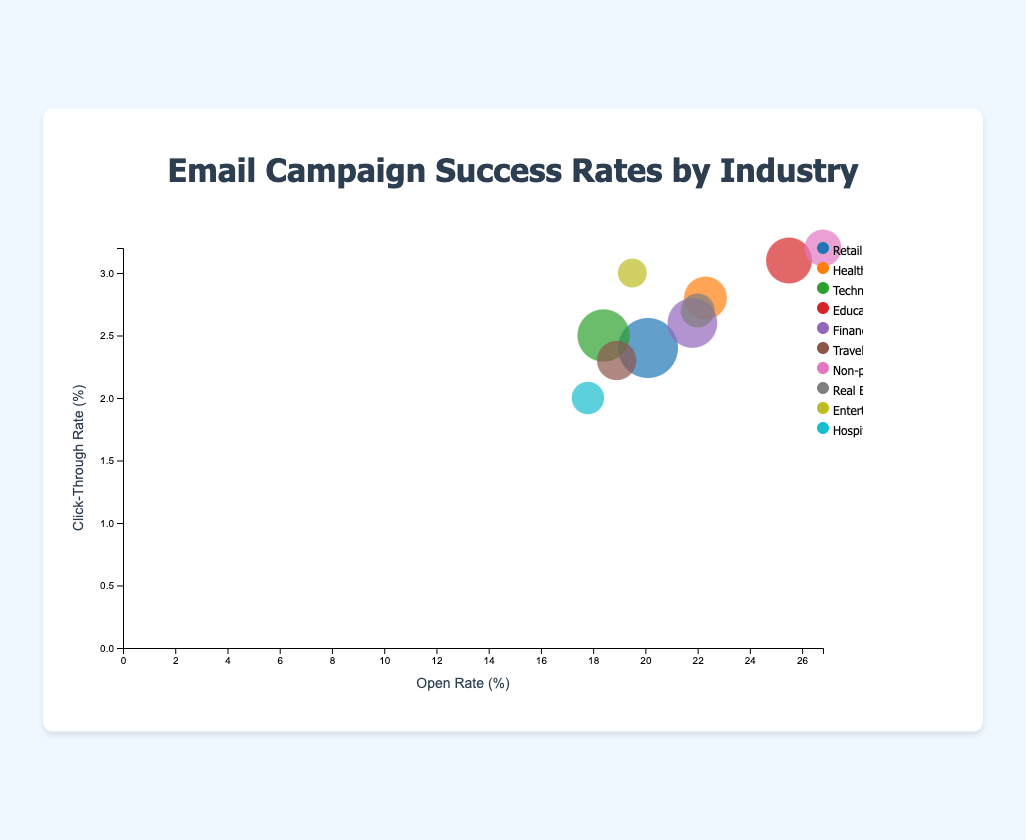What's the title of the bubble chart? The title of the chart is positioned at the top and reads: "Email Campaign Success Rates by Industry".
Answer: Email Campaign Success Rates by Industry Which industry has the largest number of email campaigns? The size of the bubbles represents the number of email campaigns. The largest bubble corresponds to Retail, which has 35 email campaigns.
Answer: Retail What is the open rate for the Non-profit industry? Hovering over the bubble for the Non-profit sector shows the open rate is 26.8%.
Answer: 26.8% Which industry has the highest click-through rate (CTR)? By comparing the y-positions of the bubbles, the highest CTR is for the Non-profit industry, which has a CTR of 3.2%.
Answer: Non-profit How many email campaigns does the Healthcare industry have? Hovering over the Healthcare industry bubble brings up the tooltip indicating that it has 15 email campaigns.
Answer: 15 Which industry has the lowest conversion rate? The tooltip for the Hospitality bubble reveals it has the lowest conversion rate, which is 1.5%.
Answer: Hospitality Calculate the average open rate of the Retail and Technology industries. The Retail industry has an open rate of 20.1%, and Technology has an open rate of 18.4%. The average is (20.1 + 18.4) / 2 = 19.25%.
Answer: 19.25% Between Healthcare and Finance, which has a higher click-through rate and by how much? The Healthcare industry has a click-through rate of 2.8%, while Finance has 2.6%. The difference is 2.8% - 2.6% = 0.2%.
Answer: Healthcare by 0.2% What is the sum of conversion rates for Education and Entertainment industries? The conversion rate for Education is 2.5% and for Entertainment is 2.1%. The sum is 2.5% + 2.1% = 4.6%.
Answer: 4.6% Which industry has a higher combination of open and click-through rates: Travel or Real Estate? Travel: open rate 18.9, CTR 2.3. Sum = 18.9 + 2.3 = 21.2. Real Estate: open rate 22, CTR 2.7. Sum = 22 + 2.7 = 24.7. Real Estate has the higher combined rate.
Answer: Real Estate 